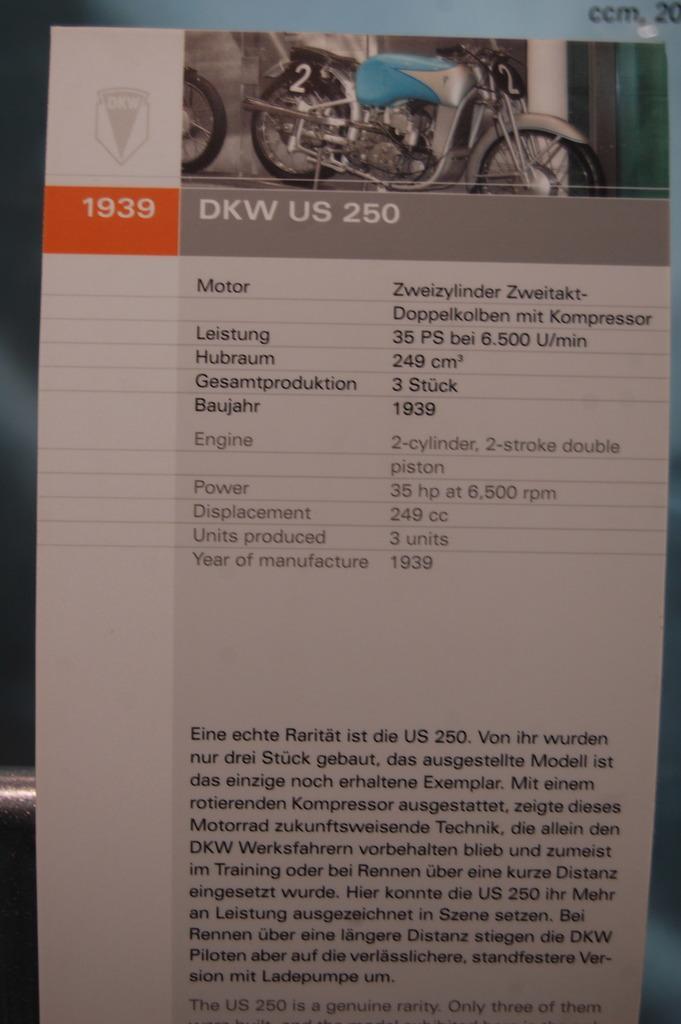Describe this image in one or two sentences. In this picture I can observe specifications of a motorbike on the paper. There is some text on the paper. On the top of the paper I can observe motorbike. The background is in grey color. 